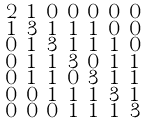Convert formula to latex. <formula><loc_0><loc_0><loc_500><loc_500>\begin{smallmatrix} 2 & 1 & 0 & 0 & 0 & 0 & 0 \\ 1 & 3 & 1 & 1 & 1 & 0 & 0 \\ 0 & 1 & 3 & 1 & 1 & 1 & 0 \\ 0 & 1 & 1 & 3 & 0 & 1 & 1 \\ 0 & 1 & 1 & 0 & 3 & 1 & 1 \\ 0 & 0 & 1 & 1 & 1 & 3 & 1 \\ 0 & 0 & 0 & 1 & 1 & 1 & 3 \end{smallmatrix}</formula> 